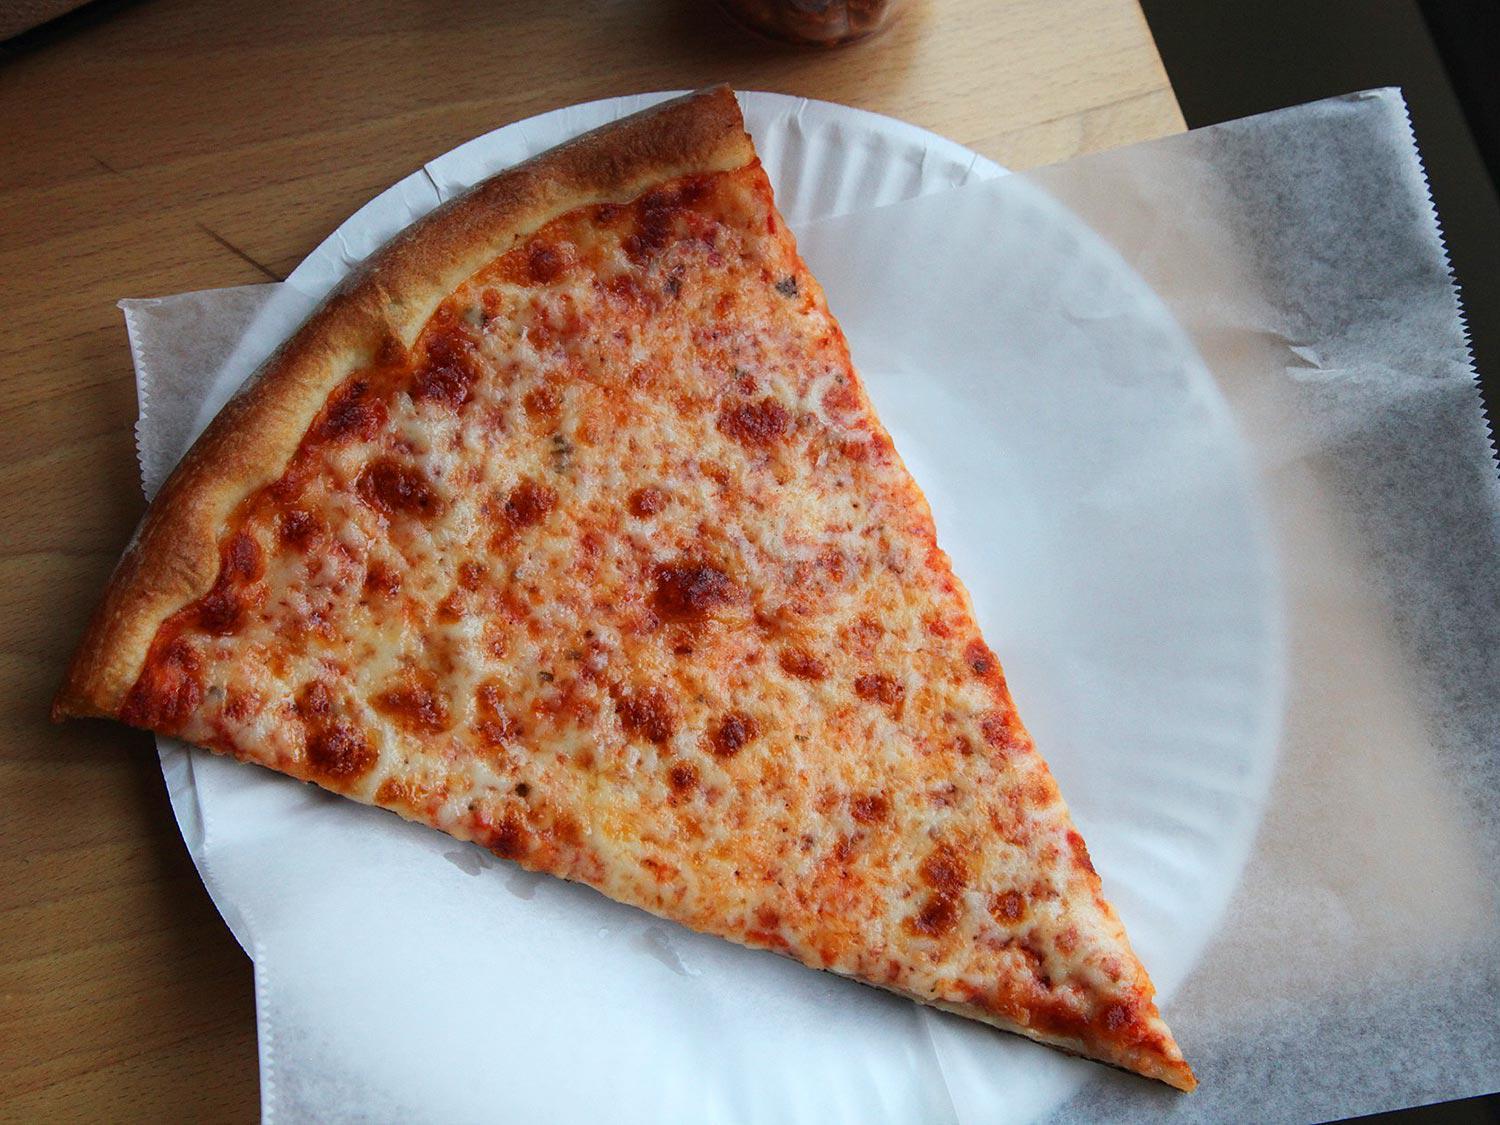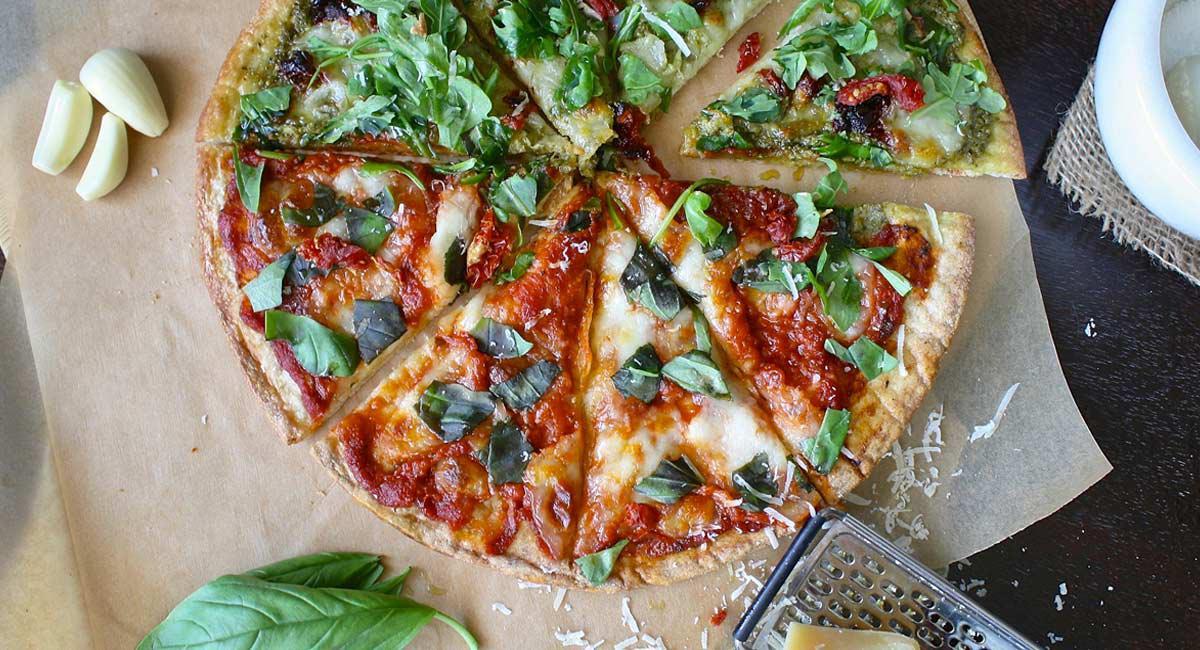The first image is the image on the left, the second image is the image on the right. Analyze the images presented: Is the assertion "A slice is being lifted off a pizza." valid? Answer yes or no. No. The first image is the image on the left, the second image is the image on the right. For the images displayed, is the sentence "A slice is being taken out of a pizza in the right image, with the cheese oozing down." factually correct? Answer yes or no. No. 